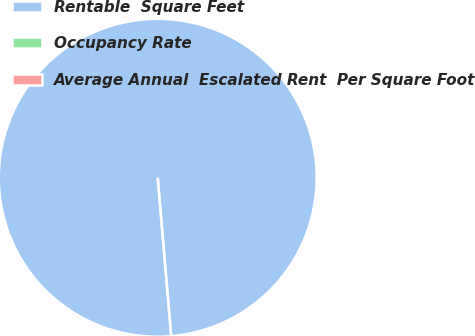<chart> <loc_0><loc_0><loc_500><loc_500><pie_chart><fcel>Rentable  Square Feet<fcel>Occupancy Rate<fcel>Average Annual  Escalated Rent  Per Square Foot<nl><fcel>100.0%<fcel>0.0%<fcel>0.0%<nl></chart> 